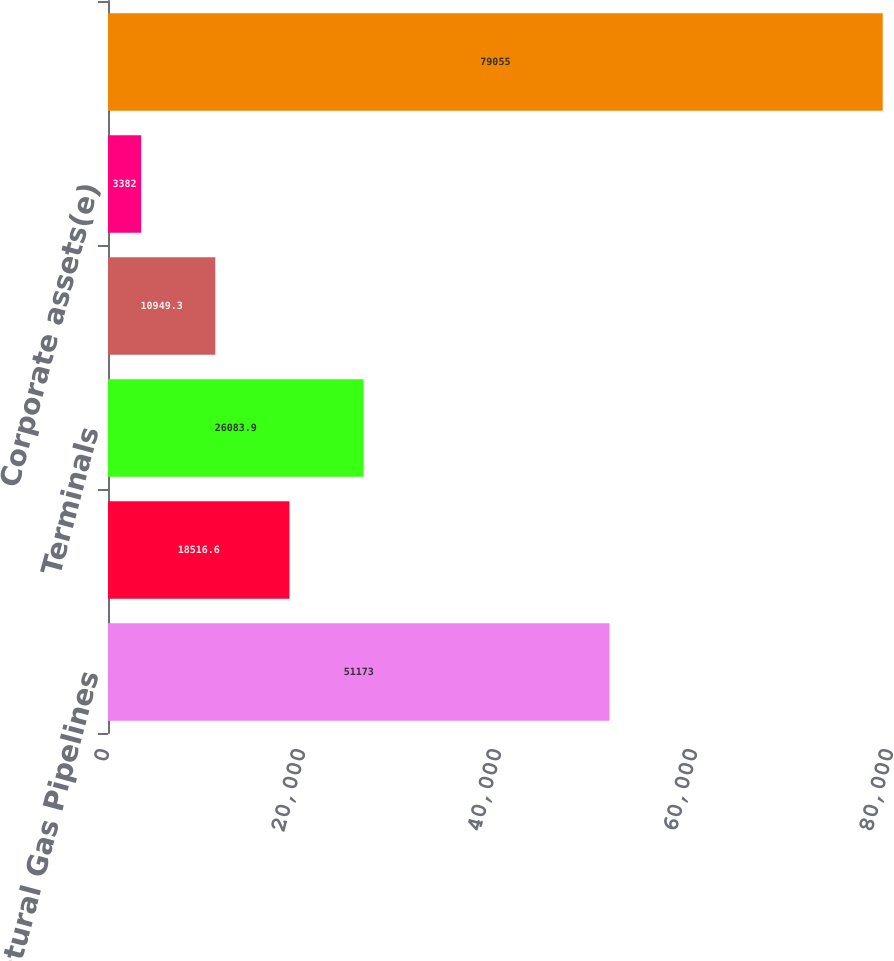Convert chart. <chart><loc_0><loc_0><loc_500><loc_500><bar_chart><fcel>Natural Gas Pipelines<fcel>Products Pipelines<fcel>Terminals<fcel>CO2<fcel>Corporate assets(e)<fcel>Total consolidated assets<nl><fcel>51173<fcel>18516.6<fcel>26083.9<fcel>10949.3<fcel>3382<fcel>79055<nl></chart> 